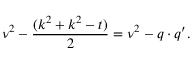<formula> <loc_0><loc_0><loc_500><loc_500>\nu ^ { 2 } - \frac { ( k ^ { 2 } + k ^ { 2 } - t ) } { 2 } = \nu ^ { 2 } - q \cdot q ^ { \prime } .</formula> 